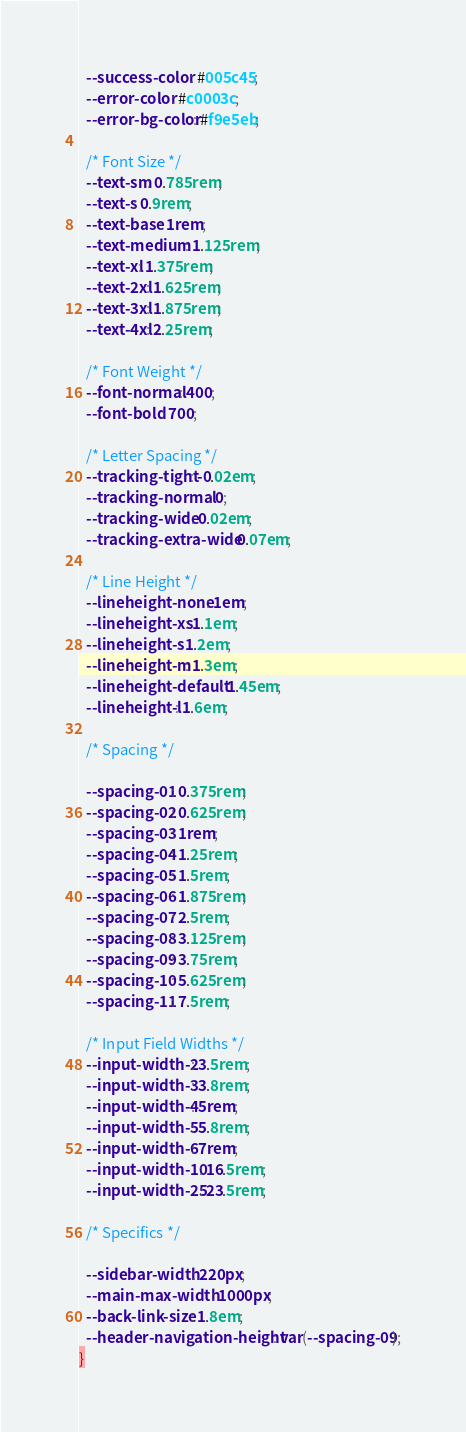Convert code to text. <code><loc_0><loc_0><loc_500><loc_500><_CSS_>
  --success-color: #005c45;
  --error-color: #c0003c;
  --error-bg-color: #f9e5eb;

  /* Font Size */
  --text-sm: 0.785rem;
  --text-s: 0.9rem;
  --text-base: 1rem;
  --text-medium: 1.125rem;
  --text-xl: 1.375rem;
  --text-2xl: 1.625rem;
  --text-3xl: 1.875rem;
  --text-4xl: 2.25rem;

  /* Font Weight */
  --font-normal: 400;
  --font-bold: 700;

  /* Letter Spacing */
  --tracking-tight: -0.02em;
  --tracking-normal: 0;
  --tracking-wide: 0.02em;
  --tracking-extra-wide: 0.07em;

  /* Line Height */
  --lineheight-none: 1em;
  --lineheight-xs: 1.1em;
  --lineheight-s: 1.2em;
  --lineheight-m: 1.3em;
  --lineheight-default: 1.45em;
  --lineheight-l: 1.6em;

  /* Spacing */

  --spacing-01: 0.375rem;
  --spacing-02: 0.625rem;
  --spacing-03: 1rem;
  --spacing-04: 1.25rem;
  --spacing-05: 1.5rem;
  --spacing-06: 1.875rem;
  --spacing-07: 2.5rem;
  --spacing-08: 3.125rem;
  --spacing-09: 3.75rem;
  --spacing-10: 5.625rem;
  --spacing-11: 7.5rem;

  /* Input Field Widths */
  --input-width-2: 3.5rem;
  --input-width-3: 3.8rem;
  --input-width-4: 5rem;
  --input-width-5: 5.8rem;
  --input-width-6: 7rem;
  --input-width-10: 16.5rem;
  --input-width-25: 23.5rem;

  /* Specifics */

  --sidebar-width: 220px;
  --main-max-width: 1000px;
  --back-link-size: 1.8em;
  --header-navigation-height: var(--spacing-09);
}
</code> 